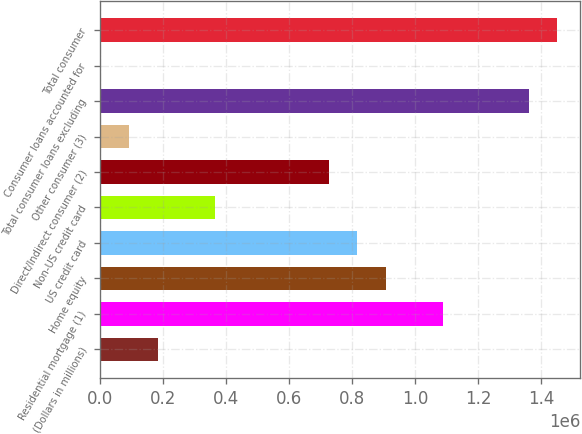Convert chart. <chart><loc_0><loc_0><loc_500><loc_500><bar_chart><fcel>(Dollars in millions)<fcel>Residential mortgage (1)<fcel>Home equity<fcel>US credit card<fcel>Non-US credit card<fcel>Direct/Indirect consumer (2)<fcel>Other consumer (3)<fcel>Total consumer loans excluding<fcel>Consumer loans accounted for<fcel>Total consumer<nl><fcel>182368<fcel>1.08918e+06<fcel>907819<fcel>817138<fcel>363731<fcel>726456<fcel>91686.4<fcel>1.36123e+06<fcel>1005<fcel>1.45191e+06<nl></chart> 